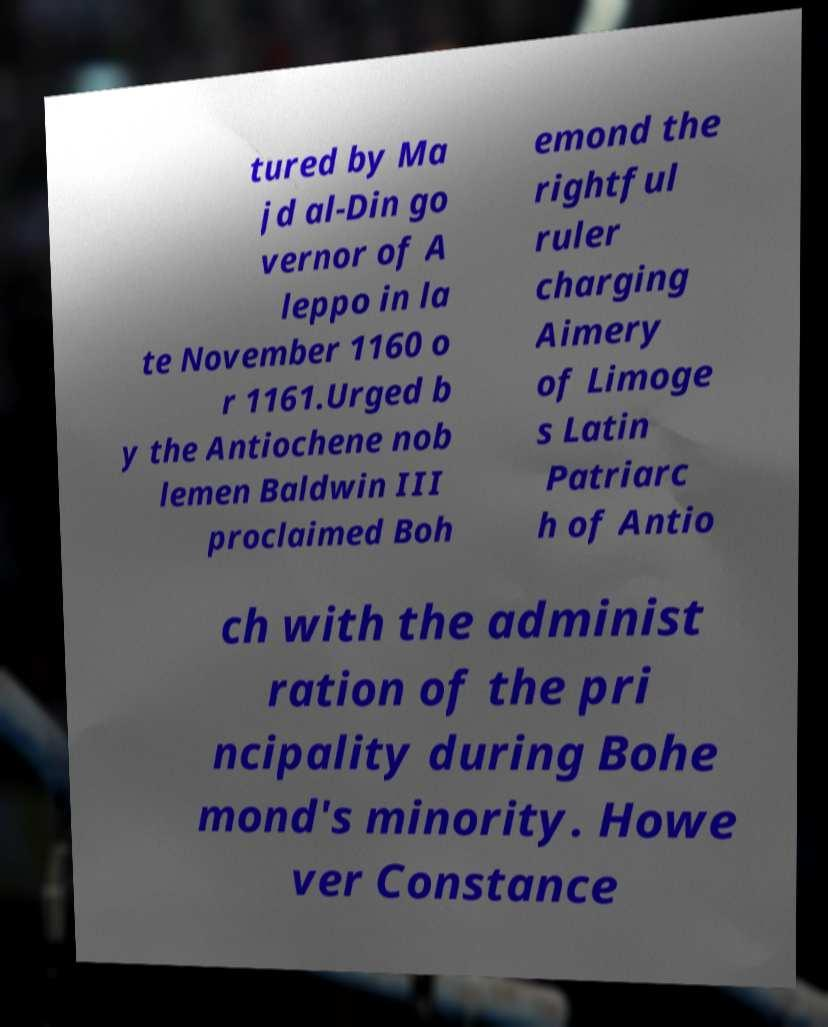For documentation purposes, I need the text within this image transcribed. Could you provide that? tured by Ma jd al-Din go vernor of A leppo in la te November 1160 o r 1161.Urged b y the Antiochene nob lemen Baldwin III proclaimed Boh emond the rightful ruler charging Aimery of Limoge s Latin Patriarc h of Antio ch with the administ ration of the pri ncipality during Bohe mond's minority. Howe ver Constance 